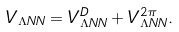<formula> <loc_0><loc_0><loc_500><loc_500>V _ { \Lambda N N } = V _ { \Lambda N N } ^ { D } + V _ { \Lambda N N } ^ { 2 \pi } .</formula> 